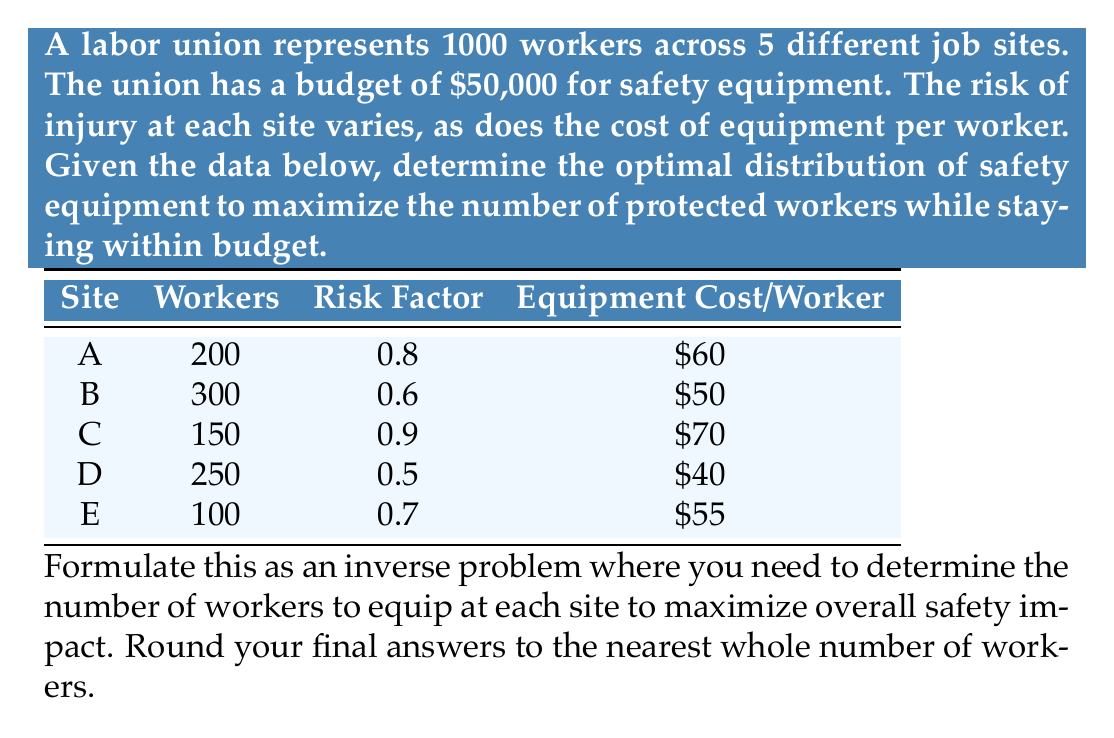Can you answer this question? To solve this inverse problem, we'll use a weighted approach based on the risk factor and number of workers at each site. We'll follow these steps:

1) Calculate a priority score for each site:
   Priority Score = Number of Workers × Risk Factor

2) Calculate the cost-effectiveness for each site:
   Cost-Effectiveness = Priority Score / Equipment Cost per Worker

3) Rank sites by cost-effectiveness.

4) Allocate budget to sites in order of cost-effectiveness until the budget is exhausted.

Step 1: Calculate priority scores
A: $200 \times 0.8 = 160$
B: $300 \times 0.6 = 180$
C: $150 \times 0.9 = 135$
D: $250 \times 0.5 = 125$
E: $100 \times 0.7 = 70$

Step 2: Calculate cost-effectiveness
A: $160 / 60 = 2.67$
B: $180 / 50 = 3.60$
C: $135 / 70 = 1.93$
D: $125 / 40 = 3.13$
E: $70 / 55 = 1.27$

Step 3: Rank sites by cost-effectiveness
1. B (3.60)
2. D (3.13)
3. A (2.67)
4. C (1.93)
5. E (1.27)

Step 4: Allocate budget
B: $300 \times $50 = $15,000$ (all 300 workers)
Budget remaining: $50,000 - $15,000 = $35,000$

D: $250 \times $40 = $10,000$ (all 250 workers)
Budget remaining: $35,000 - $10,000 = $25,000$

A: $25,000 / $60 = 416.67$ workers, but only 200 available
   $200 \times $60 = $12,000$ (all 200 workers)
Budget remaining: $25,000 - $12,000 = $13,000$

C: $13,000 / $70 = 185.71$ workers, but only 150 available
   $150 \times $70 = $10,500$ (all 150 workers)
Budget remaining: $13,000 - $10,500 = $2,500$

E: $2,500 / $55 = 45.45$ workers
   Round to 45 workers: $45 \times $55 = $2,475$

Final allocation:
B: 300 workers
D: 250 workers
A: 200 workers
C: 150 workers
E: 45 workers
Answer: B: 300, D: 250, A: 200, C: 150, E: 45 